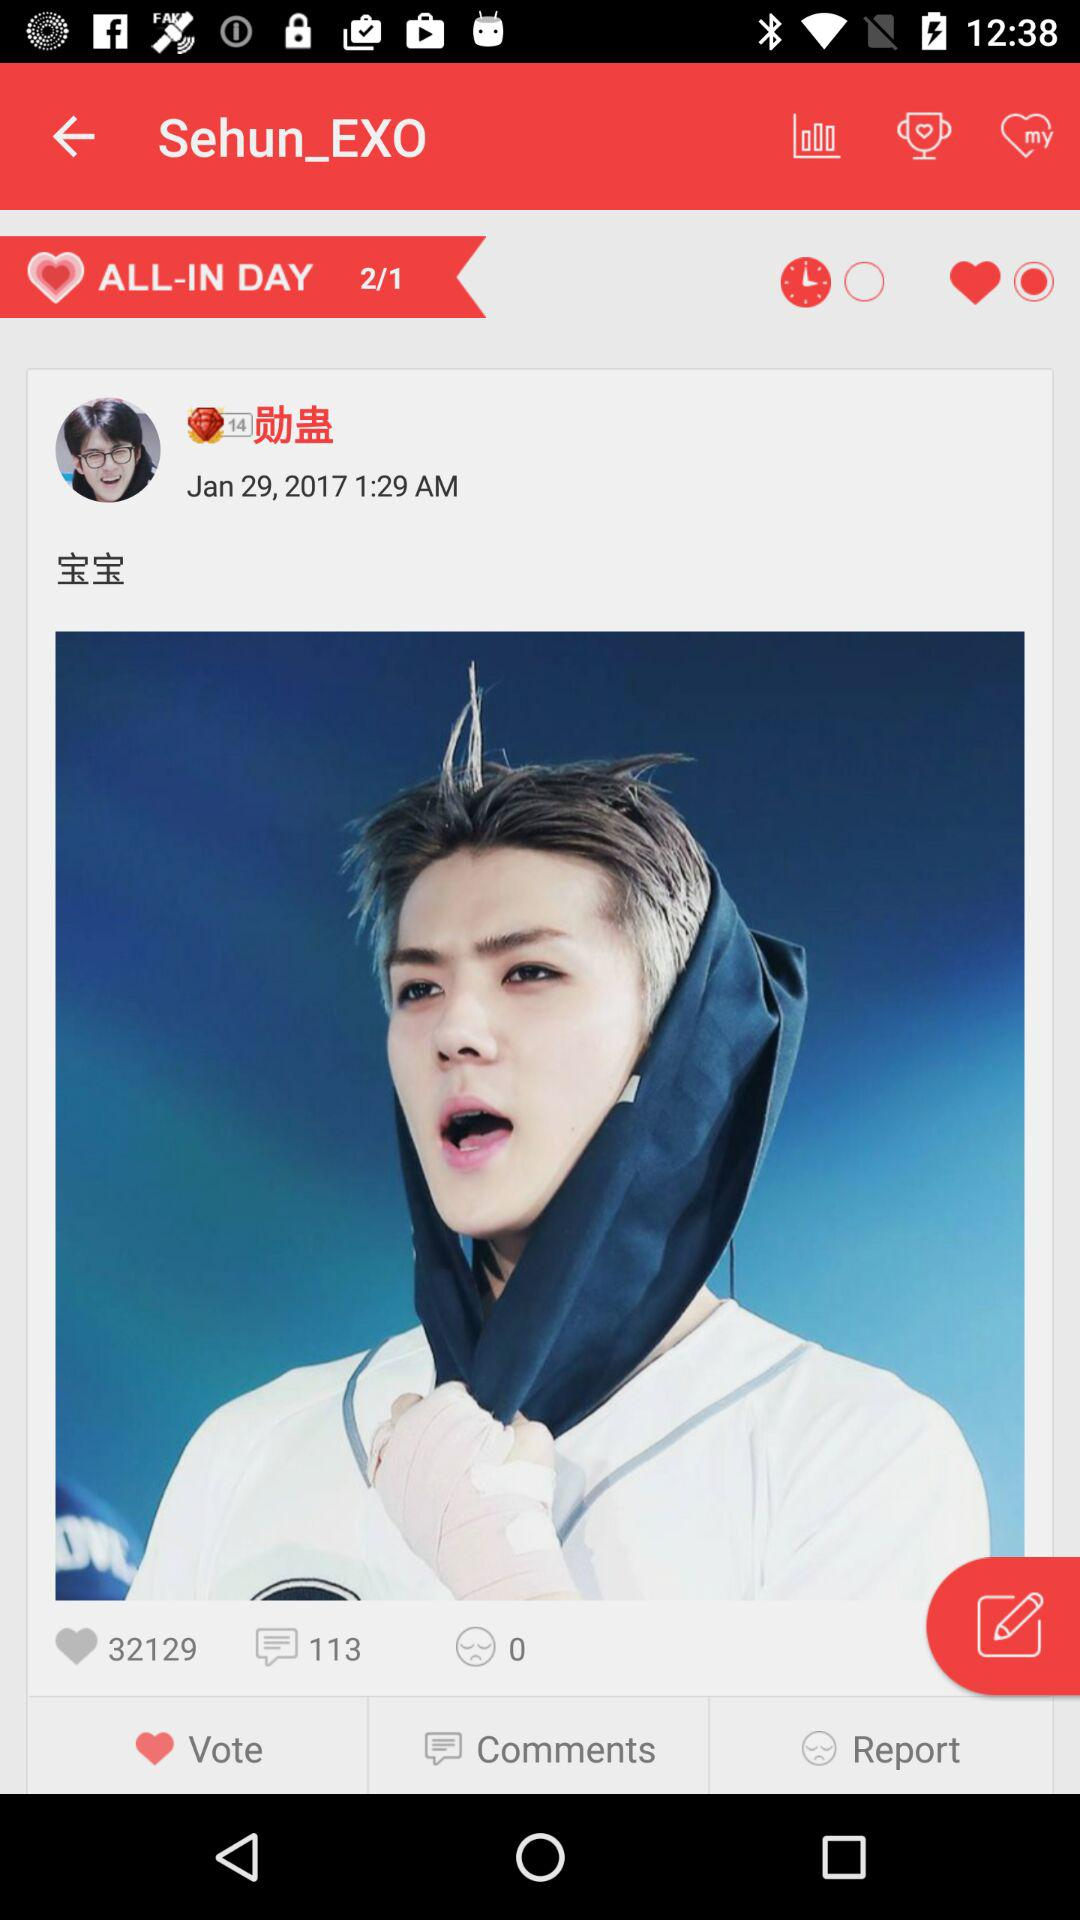How many likes are there? There are 32129 likes. 